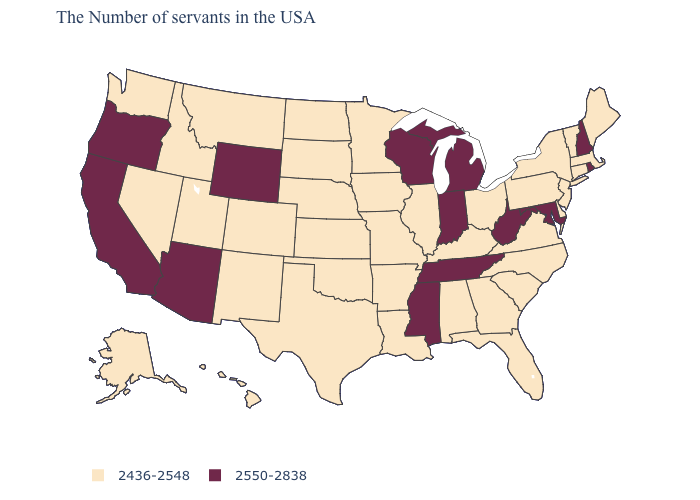Which states have the highest value in the USA?
Write a very short answer. Rhode Island, New Hampshire, Maryland, West Virginia, Michigan, Indiana, Tennessee, Wisconsin, Mississippi, Wyoming, Arizona, California, Oregon. Name the states that have a value in the range 2436-2548?
Keep it brief. Maine, Massachusetts, Vermont, Connecticut, New York, New Jersey, Delaware, Pennsylvania, Virginia, North Carolina, South Carolina, Ohio, Florida, Georgia, Kentucky, Alabama, Illinois, Louisiana, Missouri, Arkansas, Minnesota, Iowa, Kansas, Nebraska, Oklahoma, Texas, South Dakota, North Dakota, Colorado, New Mexico, Utah, Montana, Idaho, Nevada, Washington, Alaska, Hawaii. What is the value of California?
Short answer required. 2550-2838. What is the value of South Dakota?
Answer briefly. 2436-2548. Does Nebraska have the highest value in the MidWest?
Keep it brief. No. Name the states that have a value in the range 2436-2548?
Quick response, please. Maine, Massachusetts, Vermont, Connecticut, New York, New Jersey, Delaware, Pennsylvania, Virginia, North Carolina, South Carolina, Ohio, Florida, Georgia, Kentucky, Alabama, Illinois, Louisiana, Missouri, Arkansas, Minnesota, Iowa, Kansas, Nebraska, Oklahoma, Texas, South Dakota, North Dakota, Colorado, New Mexico, Utah, Montana, Idaho, Nevada, Washington, Alaska, Hawaii. Does Oklahoma have the lowest value in the USA?
Answer briefly. Yes. Does New Hampshire have the lowest value in the Northeast?
Short answer required. No. Does Nevada have the lowest value in the USA?
Short answer required. Yes. Which states have the lowest value in the Northeast?
Be succinct. Maine, Massachusetts, Vermont, Connecticut, New York, New Jersey, Pennsylvania. How many symbols are there in the legend?
Give a very brief answer. 2. What is the highest value in the USA?
Write a very short answer. 2550-2838. Does New Hampshire have the lowest value in the Northeast?
Concise answer only. No. What is the value of Illinois?
Concise answer only. 2436-2548. What is the highest value in the MidWest ?
Write a very short answer. 2550-2838. 